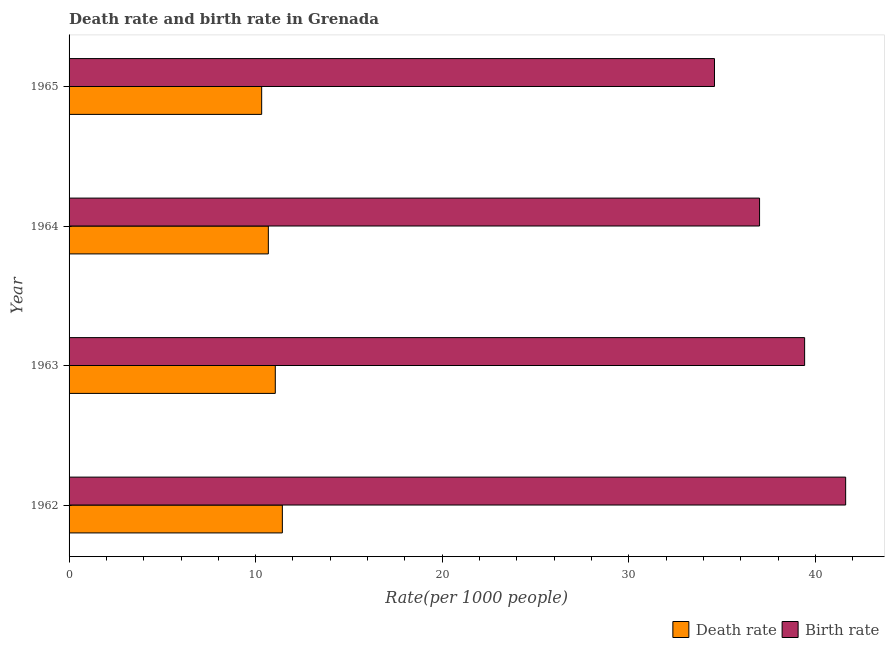Are the number of bars per tick equal to the number of legend labels?
Your answer should be very brief. Yes. What is the label of the 2nd group of bars from the top?
Keep it short and to the point. 1964. What is the death rate in 1964?
Offer a terse response. 10.68. Across all years, what is the maximum birth rate?
Make the answer very short. 41.62. Across all years, what is the minimum birth rate?
Provide a short and direct response. 34.59. In which year was the birth rate minimum?
Keep it short and to the point. 1965. What is the total death rate in the graph?
Your response must be concise. 43.49. What is the difference between the death rate in 1963 and that in 1964?
Keep it short and to the point. 0.37. What is the difference between the death rate in 1964 and the birth rate in 1963?
Ensure brevity in your answer.  -28.74. What is the average death rate per year?
Provide a short and direct response. 10.87. In the year 1964, what is the difference between the death rate and birth rate?
Keep it short and to the point. -26.33. In how many years, is the birth rate greater than 16 ?
Keep it short and to the point. 4. What is the ratio of the death rate in 1963 to that in 1965?
Keep it short and to the point. 1.07. Is the death rate in 1962 less than that in 1965?
Offer a very short reply. No. What is the difference between the highest and the second highest death rate?
Make the answer very short. 0.38. What is the difference between the highest and the lowest death rate?
Give a very brief answer. 1.11. In how many years, is the death rate greater than the average death rate taken over all years?
Provide a short and direct response. 2. Is the sum of the death rate in 1964 and 1965 greater than the maximum birth rate across all years?
Your answer should be compact. No. What does the 2nd bar from the top in 1964 represents?
Provide a succinct answer. Death rate. What does the 1st bar from the bottom in 1965 represents?
Offer a very short reply. Death rate. Are all the bars in the graph horizontal?
Your answer should be very brief. Yes. How many years are there in the graph?
Provide a short and direct response. 4. Are the values on the major ticks of X-axis written in scientific E-notation?
Your answer should be compact. No. Where does the legend appear in the graph?
Your answer should be compact. Bottom right. How many legend labels are there?
Provide a succinct answer. 2. What is the title of the graph?
Your answer should be very brief. Death rate and birth rate in Grenada. What is the label or title of the X-axis?
Your answer should be compact. Rate(per 1000 people). What is the label or title of the Y-axis?
Your answer should be compact. Year. What is the Rate(per 1000 people) in Death rate in 1962?
Your answer should be very brief. 11.43. What is the Rate(per 1000 people) in Birth rate in 1962?
Offer a very short reply. 41.62. What is the Rate(per 1000 people) of Death rate in 1963?
Provide a short and direct response. 11.05. What is the Rate(per 1000 people) of Birth rate in 1963?
Provide a short and direct response. 39.42. What is the Rate(per 1000 people) of Death rate in 1964?
Your answer should be very brief. 10.68. What is the Rate(per 1000 people) of Birth rate in 1964?
Your answer should be compact. 37.01. What is the Rate(per 1000 people) in Death rate in 1965?
Your response must be concise. 10.32. What is the Rate(per 1000 people) in Birth rate in 1965?
Offer a very short reply. 34.59. Across all years, what is the maximum Rate(per 1000 people) of Death rate?
Keep it short and to the point. 11.43. Across all years, what is the maximum Rate(per 1000 people) in Birth rate?
Offer a very short reply. 41.62. Across all years, what is the minimum Rate(per 1000 people) in Death rate?
Provide a short and direct response. 10.32. Across all years, what is the minimum Rate(per 1000 people) of Birth rate?
Make the answer very short. 34.59. What is the total Rate(per 1000 people) of Death rate in the graph?
Your answer should be compact. 43.49. What is the total Rate(per 1000 people) in Birth rate in the graph?
Provide a succinct answer. 152.65. What is the difference between the Rate(per 1000 people) in Death rate in 1962 and that in 1963?
Ensure brevity in your answer.  0.38. What is the difference between the Rate(per 1000 people) of Birth rate in 1962 and that in 1963?
Your response must be concise. 2.2. What is the difference between the Rate(per 1000 people) in Death rate in 1962 and that in 1964?
Your answer should be compact. 0.75. What is the difference between the Rate(per 1000 people) in Birth rate in 1962 and that in 1964?
Make the answer very short. 4.62. What is the difference between the Rate(per 1000 people) of Death rate in 1962 and that in 1965?
Your answer should be very brief. 1.11. What is the difference between the Rate(per 1000 people) of Birth rate in 1962 and that in 1965?
Your answer should be very brief. 7.03. What is the difference between the Rate(per 1000 people) in Death rate in 1963 and that in 1964?
Provide a short and direct response. 0.37. What is the difference between the Rate(per 1000 people) of Birth rate in 1963 and that in 1964?
Give a very brief answer. 2.42. What is the difference between the Rate(per 1000 people) of Death rate in 1963 and that in 1965?
Make the answer very short. 0.73. What is the difference between the Rate(per 1000 people) of Birth rate in 1963 and that in 1965?
Provide a short and direct response. 4.83. What is the difference between the Rate(per 1000 people) in Death rate in 1964 and that in 1965?
Your answer should be very brief. 0.36. What is the difference between the Rate(per 1000 people) of Birth rate in 1964 and that in 1965?
Make the answer very short. 2.42. What is the difference between the Rate(per 1000 people) of Death rate in 1962 and the Rate(per 1000 people) of Birth rate in 1963?
Your response must be concise. -27.99. What is the difference between the Rate(per 1000 people) of Death rate in 1962 and the Rate(per 1000 people) of Birth rate in 1964?
Provide a succinct answer. -25.58. What is the difference between the Rate(per 1000 people) in Death rate in 1962 and the Rate(per 1000 people) in Birth rate in 1965?
Make the answer very short. -23.16. What is the difference between the Rate(per 1000 people) of Death rate in 1963 and the Rate(per 1000 people) of Birth rate in 1964?
Offer a very short reply. -25.96. What is the difference between the Rate(per 1000 people) in Death rate in 1963 and the Rate(per 1000 people) in Birth rate in 1965?
Provide a succinct answer. -23.54. What is the difference between the Rate(per 1000 people) of Death rate in 1964 and the Rate(per 1000 people) of Birth rate in 1965?
Your answer should be compact. -23.91. What is the average Rate(per 1000 people) of Death rate per year?
Give a very brief answer. 10.87. What is the average Rate(per 1000 people) in Birth rate per year?
Give a very brief answer. 38.16. In the year 1962, what is the difference between the Rate(per 1000 people) of Death rate and Rate(per 1000 people) of Birth rate?
Provide a short and direct response. -30.19. In the year 1963, what is the difference between the Rate(per 1000 people) of Death rate and Rate(per 1000 people) of Birth rate?
Your answer should be very brief. -28.37. In the year 1964, what is the difference between the Rate(per 1000 people) in Death rate and Rate(per 1000 people) in Birth rate?
Your answer should be compact. -26.33. In the year 1965, what is the difference between the Rate(per 1000 people) of Death rate and Rate(per 1000 people) of Birth rate?
Make the answer very short. -24.27. What is the ratio of the Rate(per 1000 people) in Death rate in 1962 to that in 1963?
Offer a terse response. 1.03. What is the ratio of the Rate(per 1000 people) of Birth rate in 1962 to that in 1963?
Provide a short and direct response. 1.06. What is the ratio of the Rate(per 1000 people) of Death rate in 1962 to that in 1964?
Keep it short and to the point. 1.07. What is the ratio of the Rate(per 1000 people) in Birth rate in 1962 to that in 1964?
Give a very brief answer. 1.12. What is the ratio of the Rate(per 1000 people) of Death rate in 1962 to that in 1965?
Offer a terse response. 1.11. What is the ratio of the Rate(per 1000 people) in Birth rate in 1962 to that in 1965?
Offer a very short reply. 1.2. What is the ratio of the Rate(per 1000 people) of Death rate in 1963 to that in 1964?
Offer a very short reply. 1.03. What is the ratio of the Rate(per 1000 people) of Birth rate in 1963 to that in 1964?
Make the answer very short. 1.07. What is the ratio of the Rate(per 1000 people) in Death rate in 1963 to that in 1965?
Make the answer very short. 1.07. What is the ratio of the Rate(per 1000 people) in Birth rate in 1963 to that in 1965?
Your response must be concise. 1.14. What is the ratio of the Rate(per 1000 people) in Death rate in 1964 to that in 1965?
Make the answer very short. 1.03. What is the ratio of the Rate(per 1000 people) of Birth rate in 1964 to that in 1965?
Offer a terse response. 1.07. What is the difference between the highest and the second highest Rate(per 1000 people) of Death rate?
Give a very brief answer. 0.38. What is the difference between the highest and the lowest Rate(per 1000 people) of Death rate?
Provide a succinct answer. 1.11. What is the difference between the highest and the lowest Rate(per 1000 people) in Birth rate?
Make the answer very short. 7.03. 